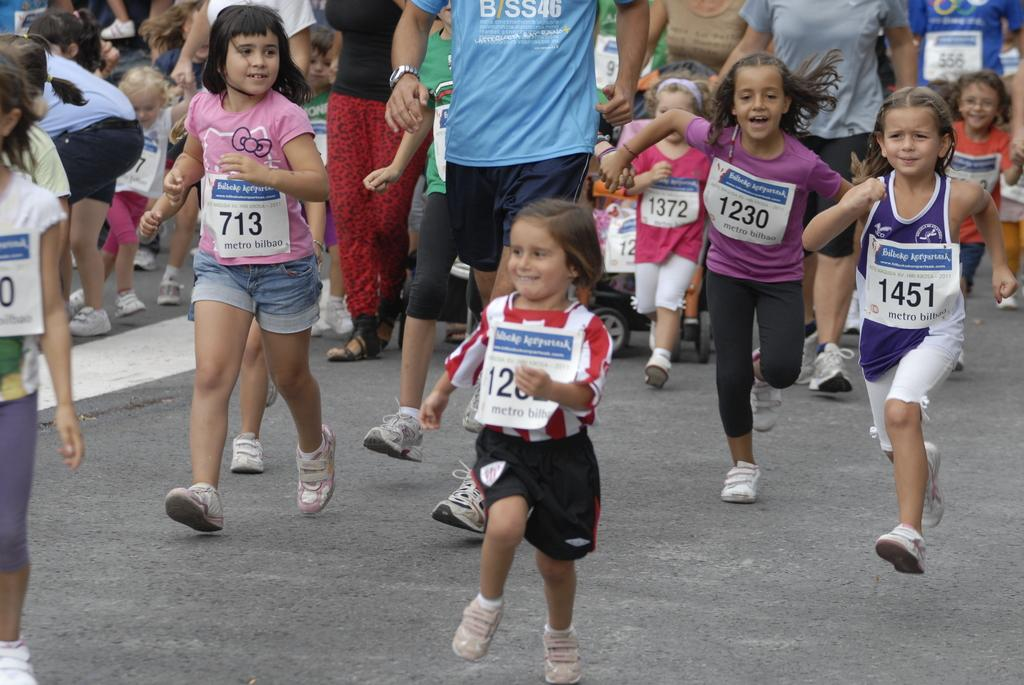<image>
Create a compact narrative representing the image presented. A little girl in a pink shirt is wearing tag number 713. 